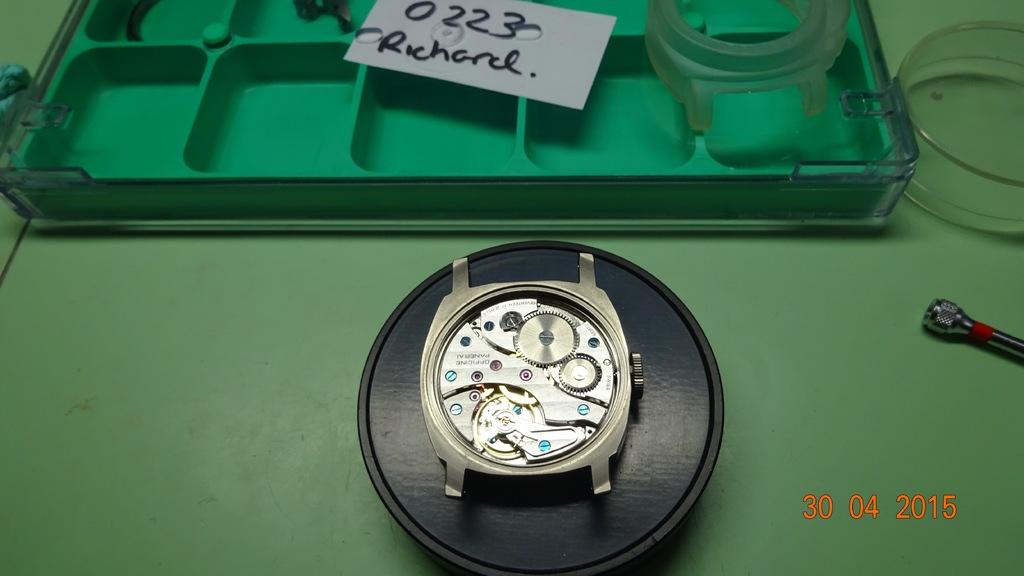<image>
Summarize the visual content of the image. Face of a watch with a piece of paper which says Richard on it. 